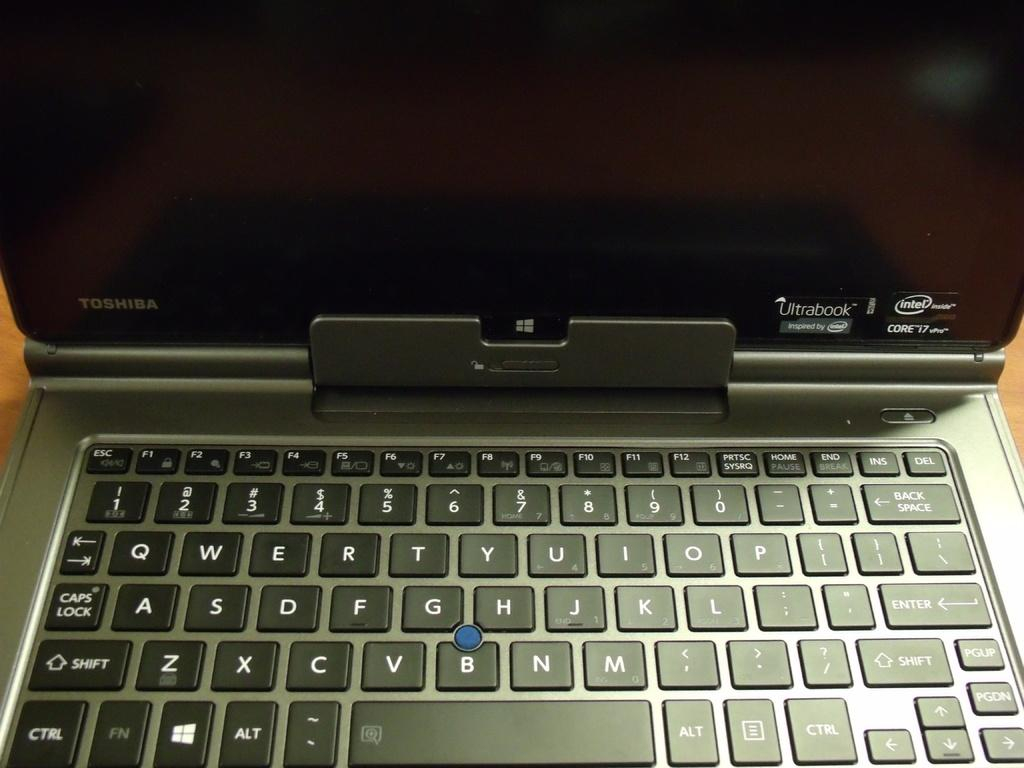Provide a one-sentence caption for the provided image. An open toshiba laptop with an intel processor. 